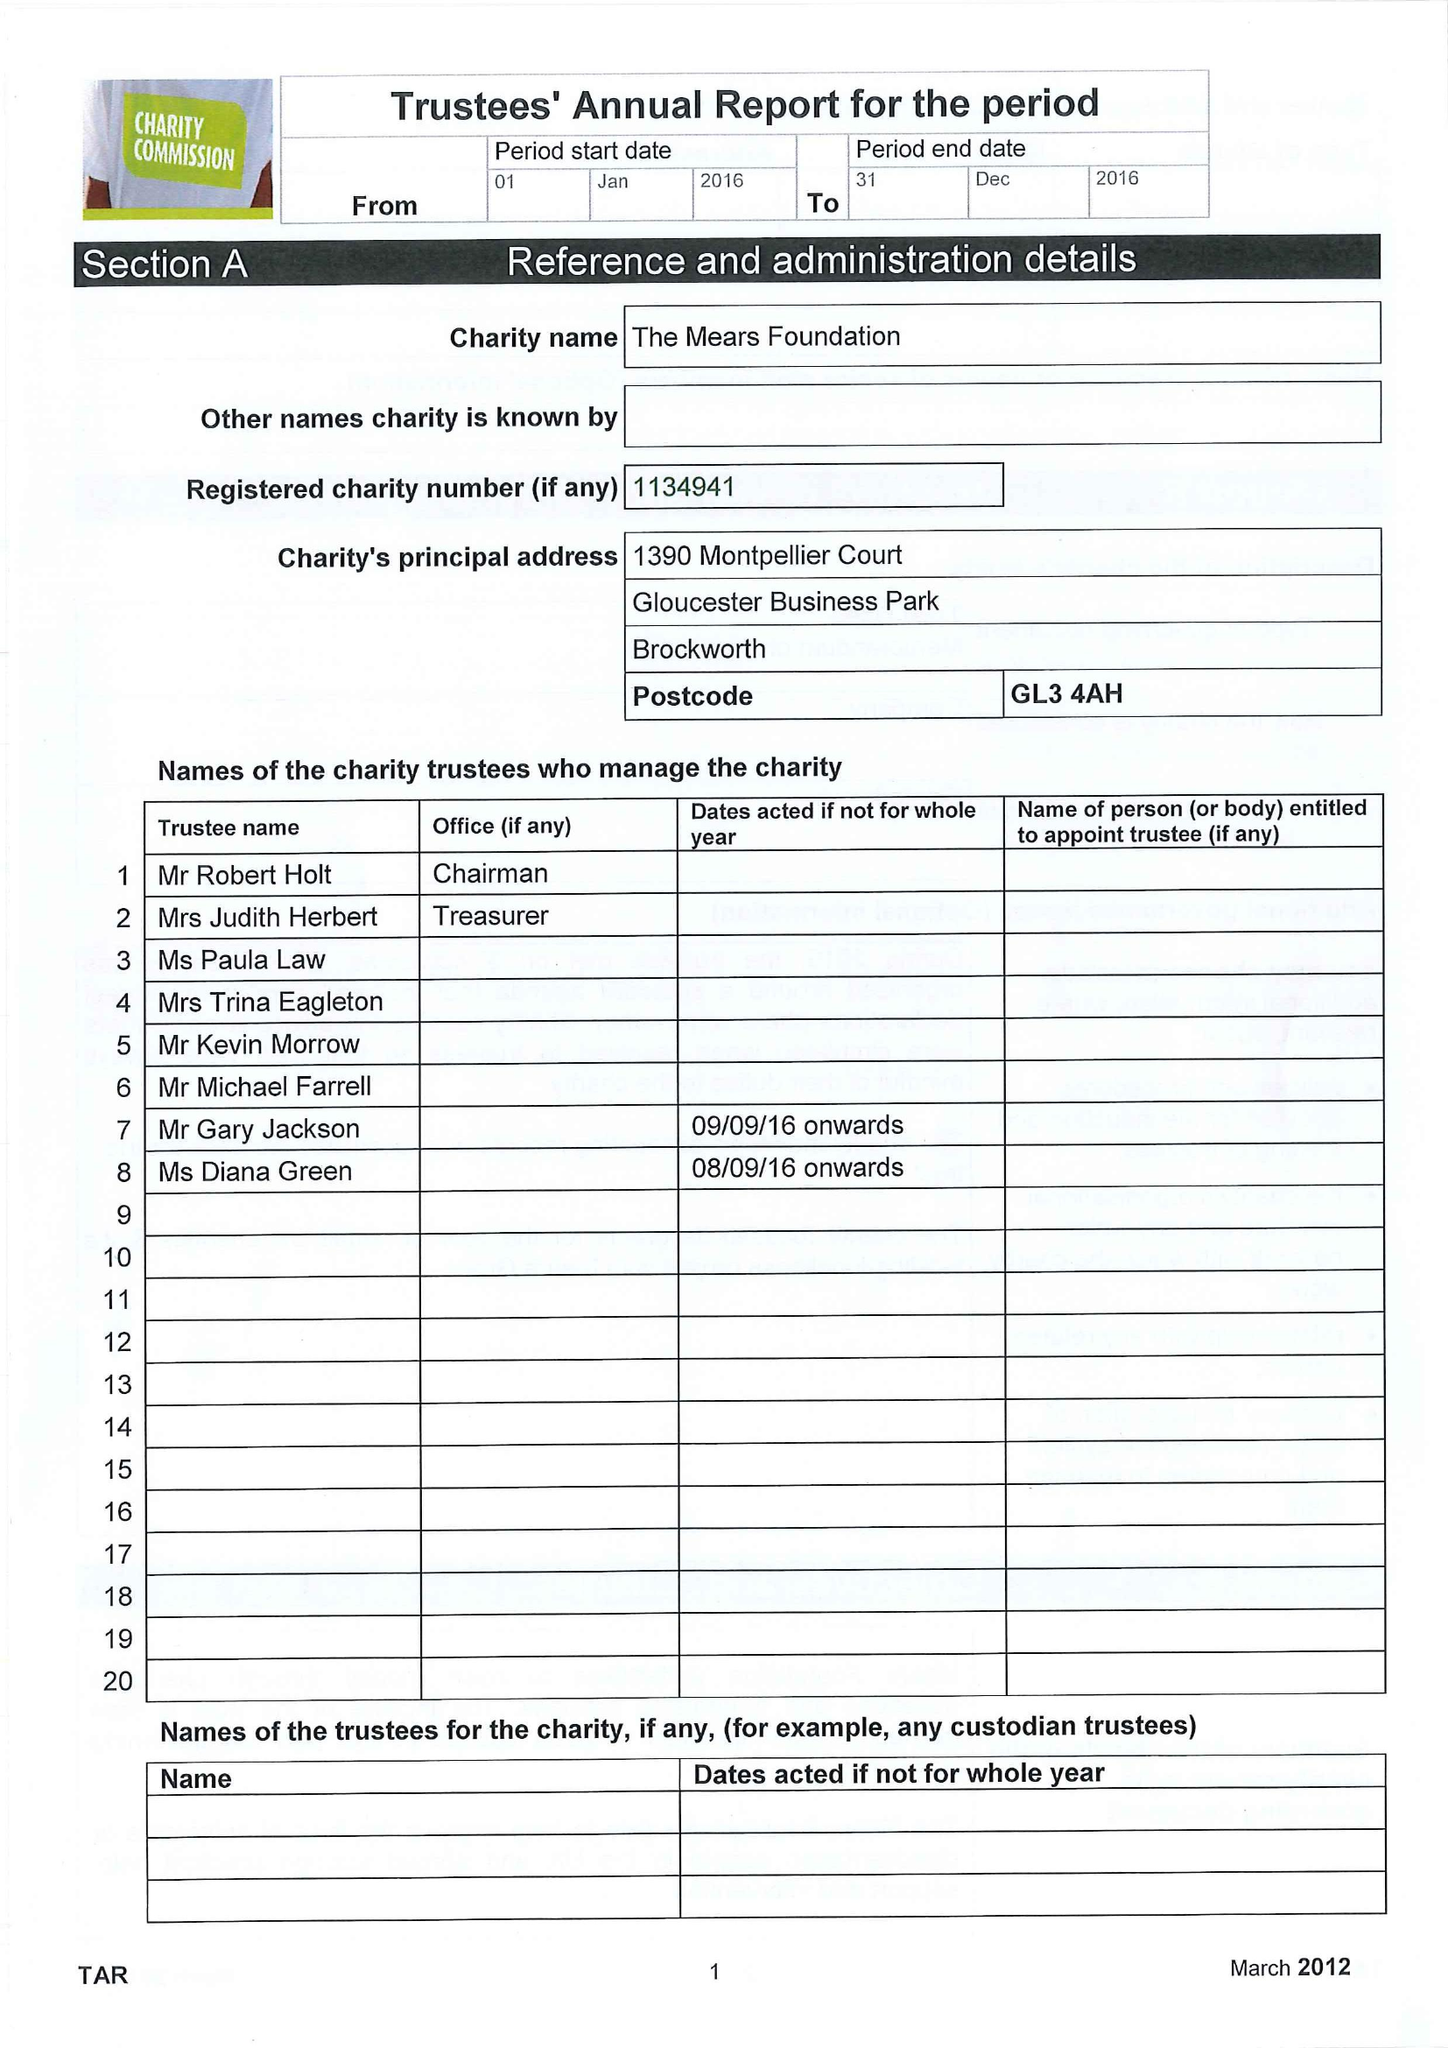What is the value for the spending_annually_in_british_pounds?
Answer the question using a single word or phrase. 12197.00 